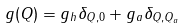Convert formula to latex. <formula><loc_0><loc_0><loc_500><loc_500>g ( Q ) = g _ { h } \delta _ { Q , 0 } + g _ { a } \delta _ { Q , Q _ { a } }</formula> 